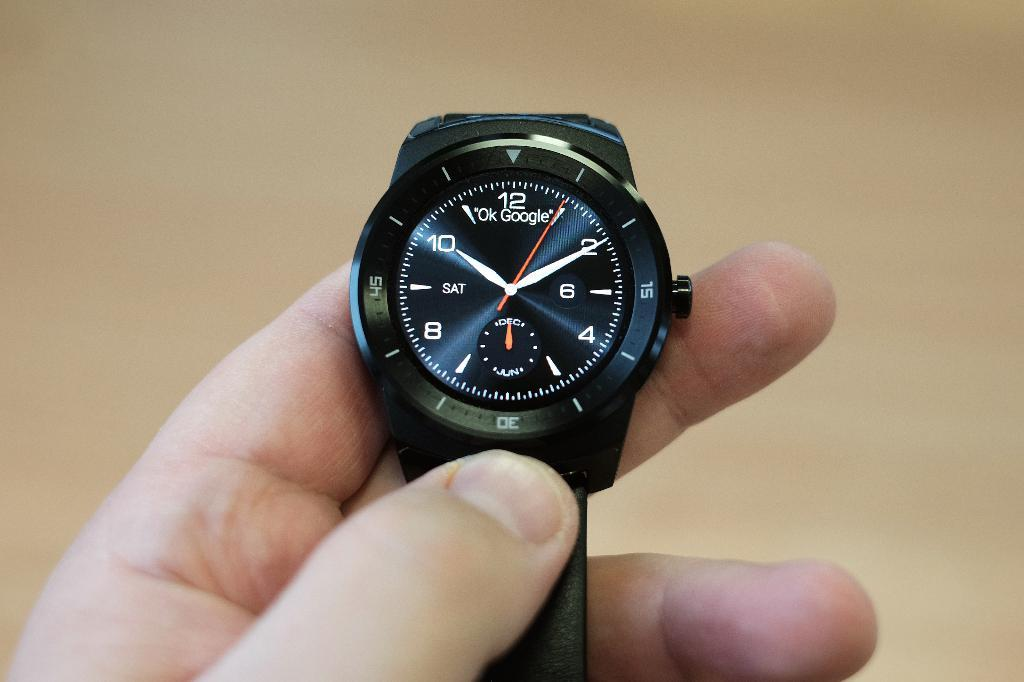<image>
Write a terse but informative summary of the picture. A watch shows the words "OK Google" on the face. 